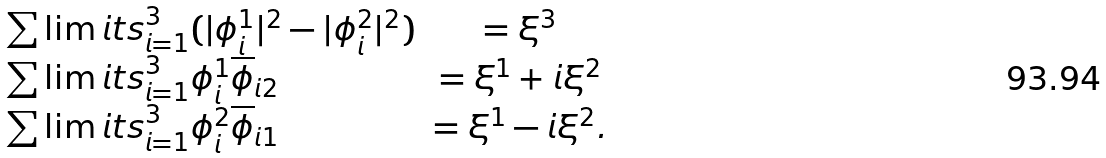Convert formula to latex. <formula><loc_0><loc_0><loc_500><loc_500>\begin{array} { l c r } \sum \lim i t s _ { i = 1 } ^ { 3 } ( | \phi ^ { 1 } _ { i } | ^ { 2 } - | \phi ^ { 2 } _ { i } | ^ { 2 } ) & = \xi ^ { 3 } \quad & \\ \sum \lim i t s _ { i = 1 } ^ { 3 } \phi ^ { 1 } _ { i } \overline { \phi } _ { i 2 } & = \xi ^ { 1 } + i { \xi ^ { 2 } } \quad & \\ \sum \lim i t s _ { i = 1 } ^ { 3 } \phi ^ { 2 } _ { i } \overline { \phi } _ { i 1 } & = \xi ^ { 1 } - i { \xi ^ { 2 } } . \quad & \end{array}</formula> 